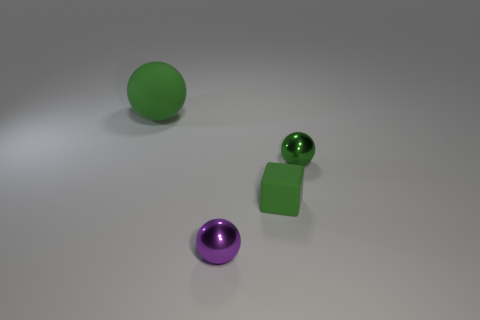Add 1 rubber spheres. How many objects exist? 5 Subtract all balls. How many objects are left? 1 Add 2 metal objects. How many metal objects are left? 4 Add 4 tiny matte cubes. How many tiny matte cubes exist? 5 Subtract 0 purple blocks. How many objects are left? 4 Subtract all green balls. Subtract all yellow matte blocks. How many objects are left? 2 